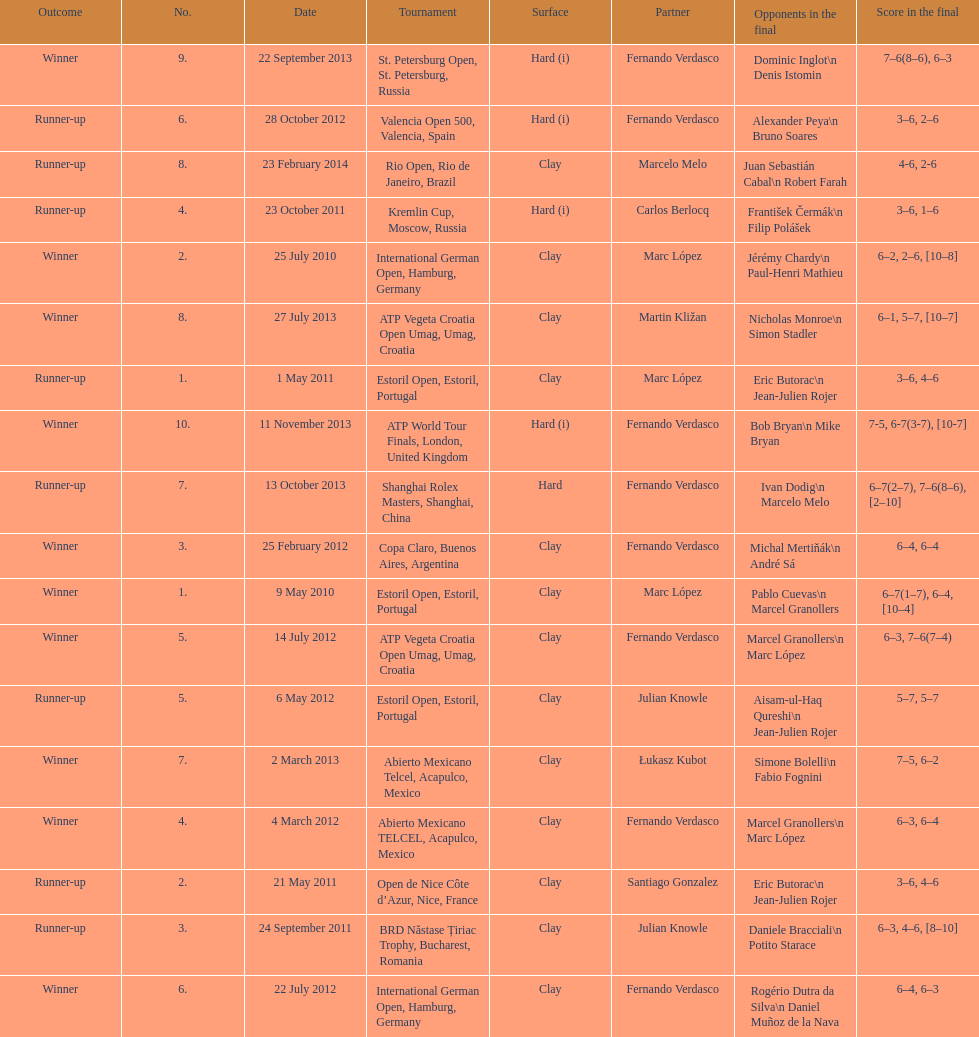Which tournament has the largest number? ATP World Tour Finals. 